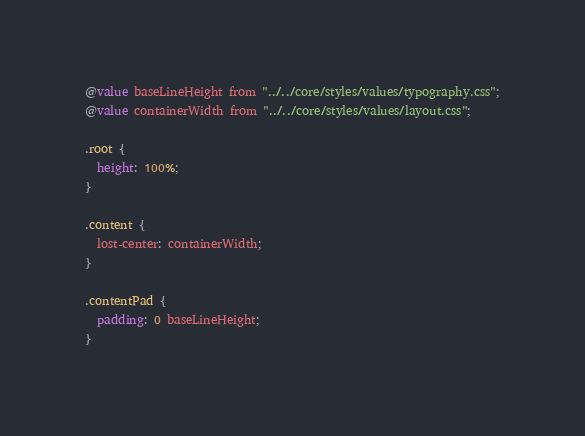<code> <loc_0><loc_0><loc_500><loc_500><_CSS_>@value baseLineHeight from "../../core/styles/values/typography.css";
@value containerWidth from "../../core/styles/values/layout.css";

.root {
  height: 100%;
}

.content {
  lost-center: containerWidth;
}

.contentPad {
  padding: 0 baseLineHeight;
}
</code> 